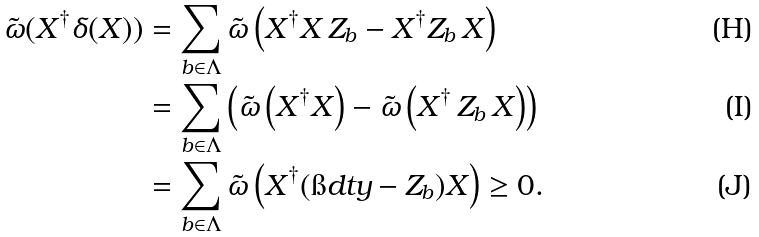Convert formula to latex. <formula><loc_0><loc_0><loc_500><loc_500>\tilde { \omega } ( X ^ { \dagger } \delta ( X ) ) & = \sum _ { b \in \Lambda } \tilde { \omega } \left ( X ^ { \dagger } X \, Z _ { b } - X ^ { \dagger } Z _ { b } \, X \right ) \\ & = \sum _ { b \in \Lambda } \left ( \tilde { \omega } \left ( X ^ { \dagger } X \right ) - \tilde { \omega } \left ( X ^ { \dagger } \, Z _ { b } \, X \right ) \right ) \\ & = \sum _ { b \in \Lambda } \tilde { \omega } \left ( X ^ { \dagger } ( \i d t y - Z _ { b } ) X \right ) \geq 0 .</formula> 